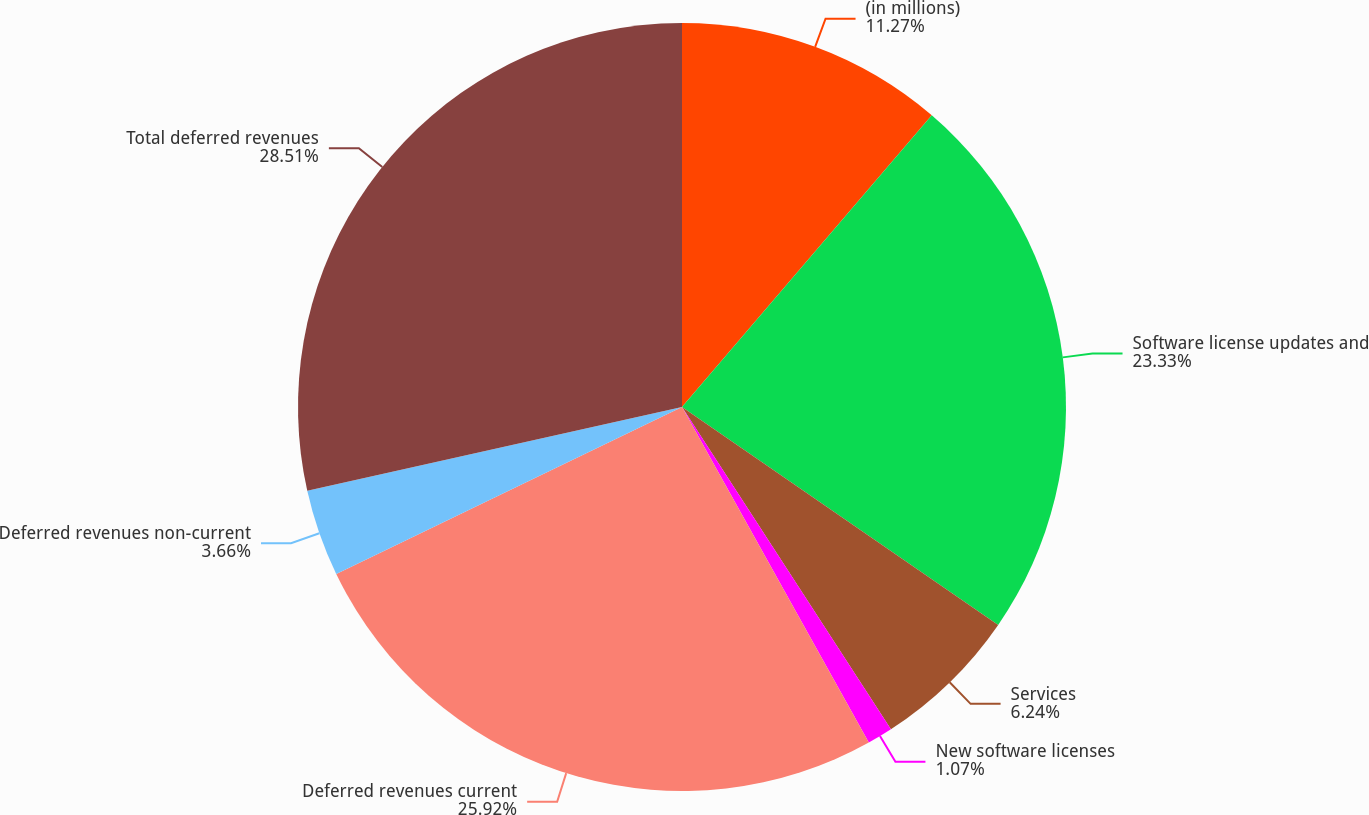Convert chart. <chart><loc_0><loc_0><loc_500><loc_500><pie_chart><fcel>(in millions)<fcel>Software license updates and<fcel>Services<fcel>New software licenses<fcel>Deferred revenues current<fcel>Deferred revenues non-current<fcel>Total deferred revenues<nl><fcel>11.27%<fcel>23.33%<fcel>6.24%<fcel>1.07%<fcel>25.92%<fcel>3.66%<fcel>28.5%<nl></chart> 